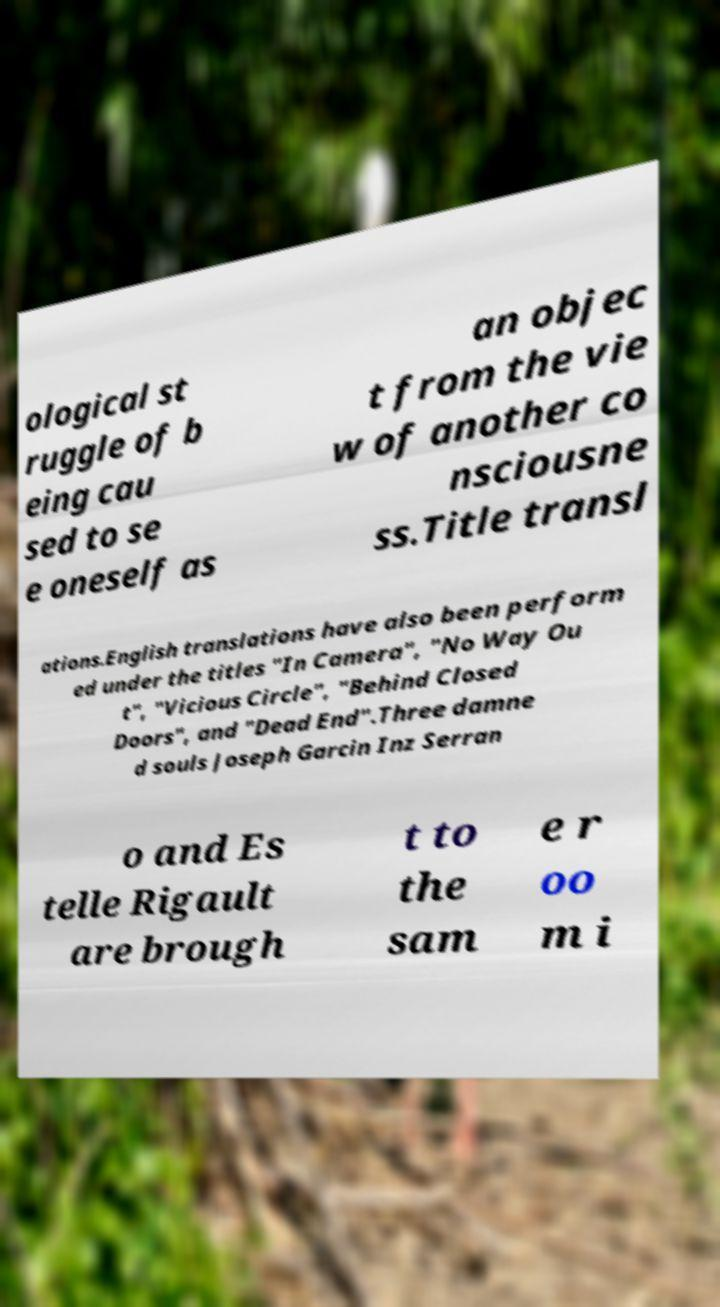Could you assist in decoding the text presented in this image and type it out clearly? ological st ruggle of b eing cau sed to se e oneself as an objec t from the vie w of another co nsciousne ss.Title transl ations.English translations have also been perform ed under the titles "In Camera", "No Way Ou t", "Vicious Circle", "Behind Closed Doors", and "Dead End".Three damne d souls Joseph Garcin Inz Serran o and Es telle Rigault are brough t to the sam e r oo m i 